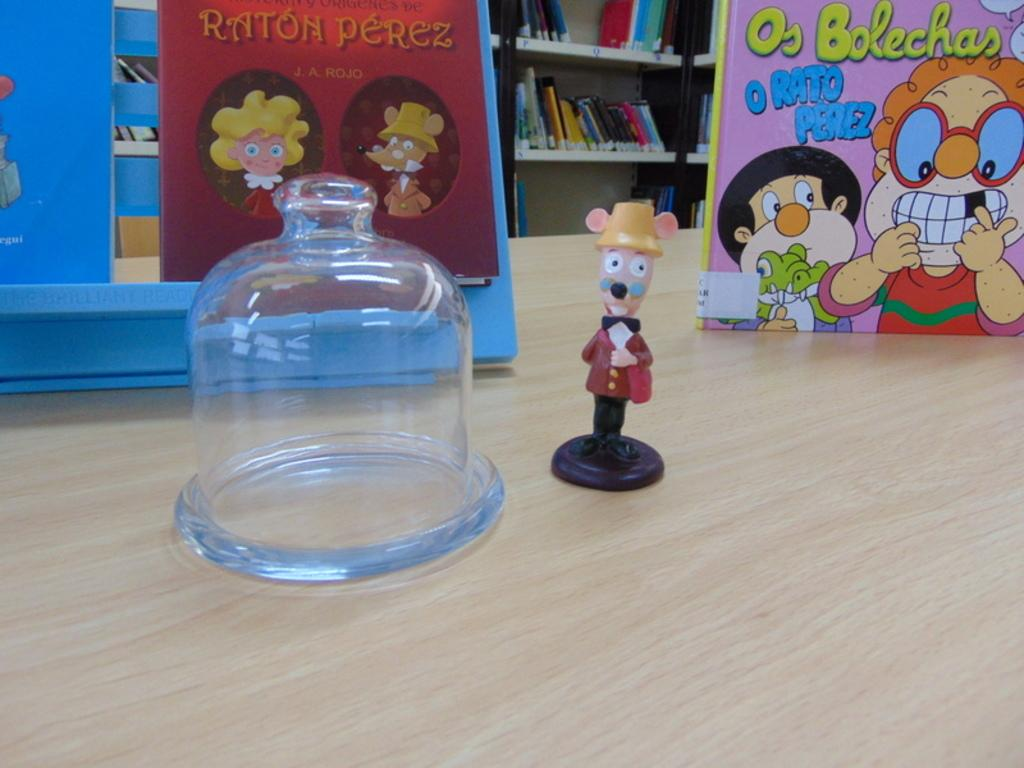<image>
Provide a brief description of the given image. Two children's book about Rato Perez sit behind a glass container 